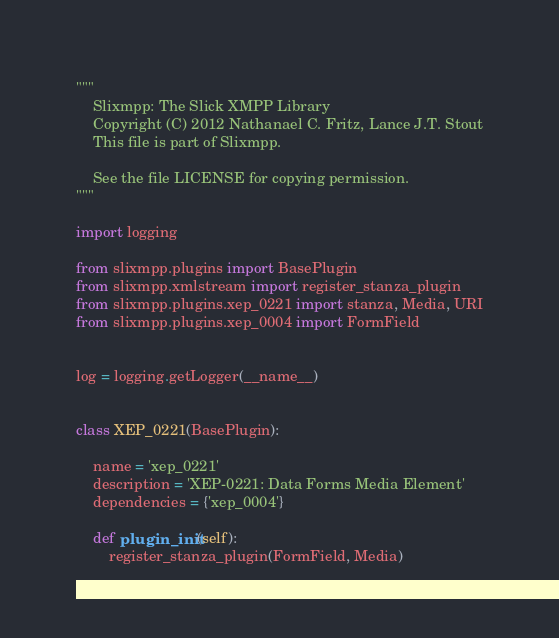Convert code to text. <code><loc_0><loc_0><loc_500><loc_500><_Python_>"""
    Slixmpp: The Slick XMPP Library
    Copyright (C) 2012 Nathanael C. Fritz, Lance J.T. Stout
    This file is part of Slixmpp.

    See the file LICENSE for copying permission.
"""

import logging

from slixmpp.plugins import BasePlugin
from slixmpp.xmlstream import register_stanza_plugin
from slixmpp.plugins.xep_0221 import stanza, Media, URI
from slixmpp.plugins.xep_0004 import FormField


log = logging.getLogger(__name__)


class XEP_0221(BasePlugin):

    name = 'xep_0221'
    description = 'XEP-0221: Data Forms Media Element'
    dependencies = {'xep_0004'}

    def plugin_init(self):
        register_stanza_plugin(FormField, Media)
</code> 